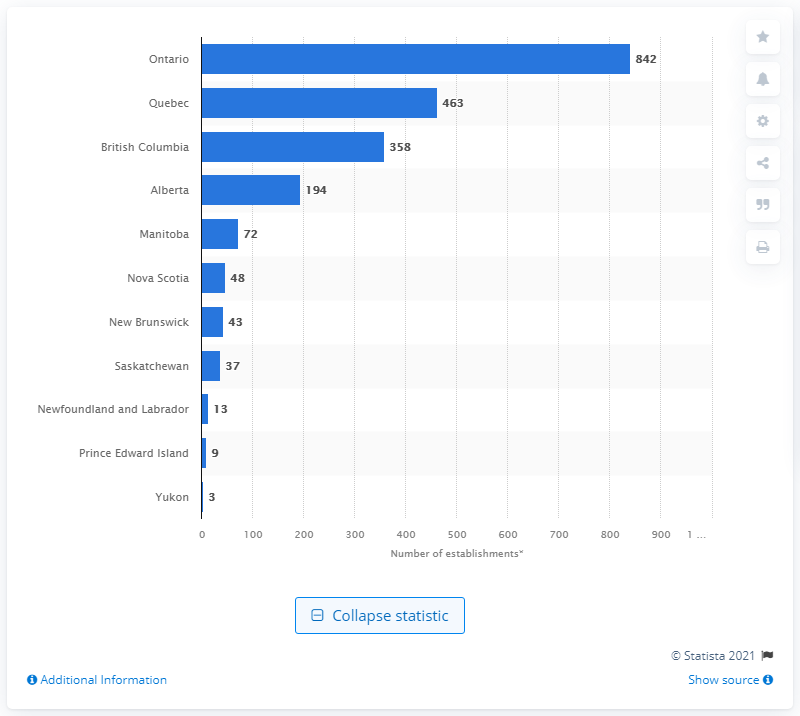Highlight a few significant elements in this photo. As of December 2020, there were 842 bakery product manufacturing establishments in the province of Ontario. 